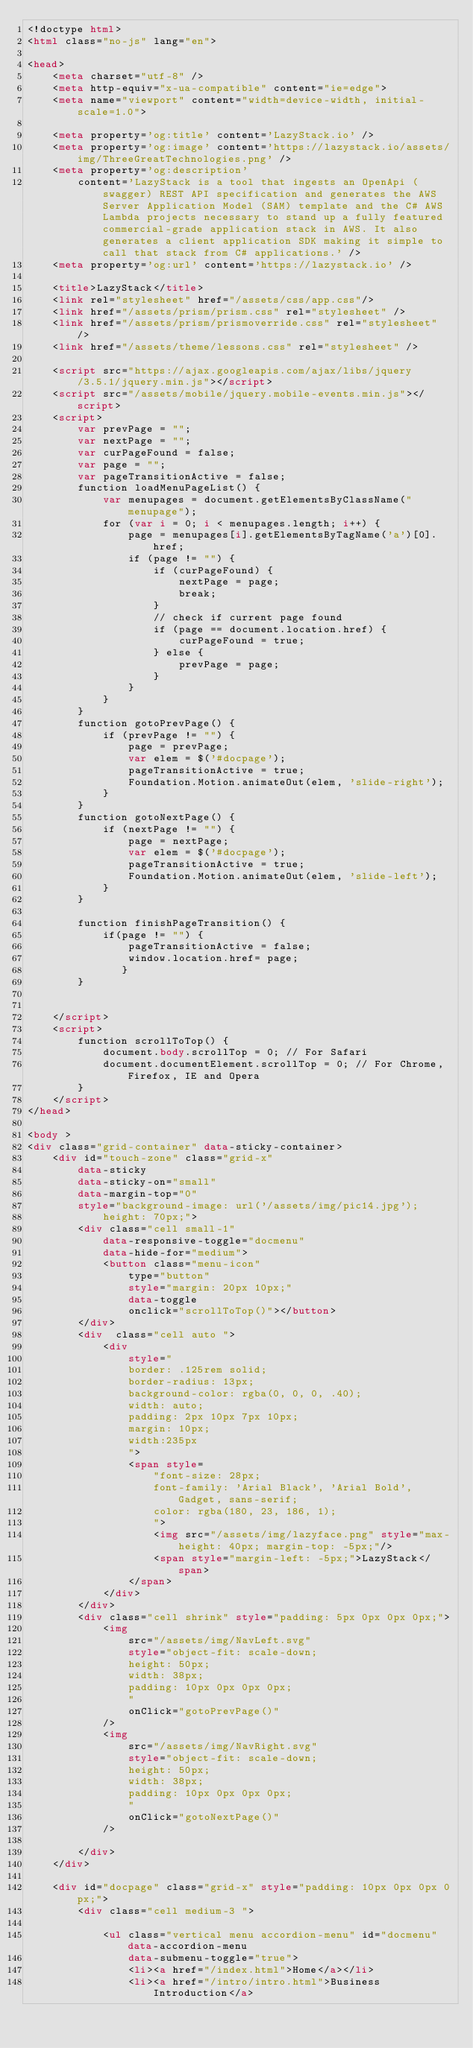<code> <loc_0><loc_0><loc_500><loc_500><_HTML_><!doctype html>
<html class="no-js" lang="en">

<head>
    <meta charset="utf-8" />
    <meta http-equiv="x-ua-compatible" content="ie=edge">
    <meta name="viewport" content="width=device-width, initial-scale=1.0">

    <meta property='og:title' content='LazyStack.io' />
    <meta property='og:image' content='https://lazystack.io/assets/img/ThreeGreatTechnologies.png' />
    <meta property='og:description'
        content='LazyStack is a tool that ingests an OpenApi (swagger) REST API specification and generates the AWS Server Application Model (SAM) template and the C# AWS Lambda projects necessary to stand up a fully featured commercial-grade application stack in AWS. It also generates a client application SDK making it simple to call that stack from C# applications.' />
    <meta property='og:url' content='https://lazystack.io' />

    <title>LazyStack</title>
    <link rel="stylesheet" href="/assets/css/app.css"/>
    <link href="/assets/prism/prism.css" rel="stylesheet" />
    <link href="/assets/prism/prismoverride.css" rel="stylesheet" />
    <link href="/assets/theme/lessons.css" rel="stylesheet" />

    <script src="https://ajax.googleapis.com/ajax/libs/jquery/3.5.1/jquery.min.js"></script>
    <script src="/assets/mobile/jquery.mobile-events.min.js"></script>
    <script>
        var prevPage = "";
        var nextPage = "";
        var curPageFound = false;
        var page = "";
        var pageTransitionActive = false;
        function loadMenuPageList() {
            var menupages = document.getElementsByClassName("menupage");
            for (var i = 0; i < menupages.length; i++) {
                page = menupages[i].getElementsByTagName('a')[0].href;
                if (page != "") {
                    if (curPageFound) {
                        nextPage = page;
                        break;
                    }
                    // check if current page found
                    if (page == document.location.href) {
                        curPageFound = true;
                    } else {
                        prevPage = page;
                    }
                }
            }
        }
        function gotoPrevPage() {
            if (prevPage != "") {
                page = prevPage;
                var elem = $('#docpage');
                pageTransitionActive = true;
                Foundation.Motion.animateOut(elem, 'slide-right');
            }
        }
        function gotoNextPage() {
            if (nextPage != "") {
                page = nextPage;
                var elem = $('#docpage');
                pageTransitionActive = true;
                Foundation.Motion.animateOut(elem, 'slide-left');
            }
        }

        function finishPageTransition() {
            if(page != "") {
                pageTransitionActive = false;
                window.location.href= page;
               }
        }


    </script>
    <script>
        function scrollToTop() {
            document.body.scrollTop = 0; // For Safari
            document.documentElement.scrollTop = 0; // For Chrome, Firefox, IE and Opera            
        }
    </script>
</head>

<body >
<div class="grid-container" data-sticky-container>
    <div id="touch-zone" class="grid-x" 
        data-sticky 
        data-sticky-on="small"
        data-margin-top="0"
        style="background-image: url('/assets/img/pic14.jpg');
            height: 70px;">
        <div class="cell small-1" 
            data-responsive-toggle="docmenu" 
            data-hide-for="medium">
            <button class="menu-icon" 
                type="button" 
                style="margin: 20px 10px;"
                data-toggle 
                onclick="scrollToTop()"></button>
        </div>
        <div  class="cell auto ">
            <div
                style="
                border: .125rem solid;
                border-radius: 13px;
                background-color: rgba(0, 0, 0, .40);
                width: auto;
                padding: 2px 10px 7px 10px;
                margin: 10px;
                width:235px
                ">
                <span style=
                    "font-size: 28px;
                    font-family: 'Arial Black', 'Arial Bold', Gadget, sans-serif;
                    color: rgba(180, 23, 186, 1);
                    ">
                    <img src="/assets/img/lazyface.png" style="max-height: 40px; margin-top: -5px;"/>  
                    <span style="margin-left: -5px;">LazyStack</span>
                </span>
            </div>
        </div>            
        <div class="cell shrink" style="padding: 5px 0px 0px 0px;">
            <img 
                src="/assets/img/NavLeft.svg" 
                style="object-fit: scale-down;
                height: 50px;
                width: 38px;
                padding: 10px 0px 0px 0px;
                " 
                onClick="gotoPrevPage()"
            />
            <img 
                src="/assets/img/NavRight.svg" 
                style="object-fit: scale-down;
                height: 50px;
                width: 38px;
                padding: 10px 0px 0px 0px;
                " 
                onClick="gotoNextPage()"
            />

        </div>
    </div>

    <div id="docpage" class="grid-x" style="padding: 10px 0px 0px 0px;">
        <div class="cell medium-3 ">
            
            <ul class="vertical menu accordion-menu" id="docmenu" data-accordion-menu 
                data-submenu-toggle="true">
                <li><a href="/index.html">Home</a></li>
                <li><a href="/intro/intro.html">Business Introduction</a></code> 